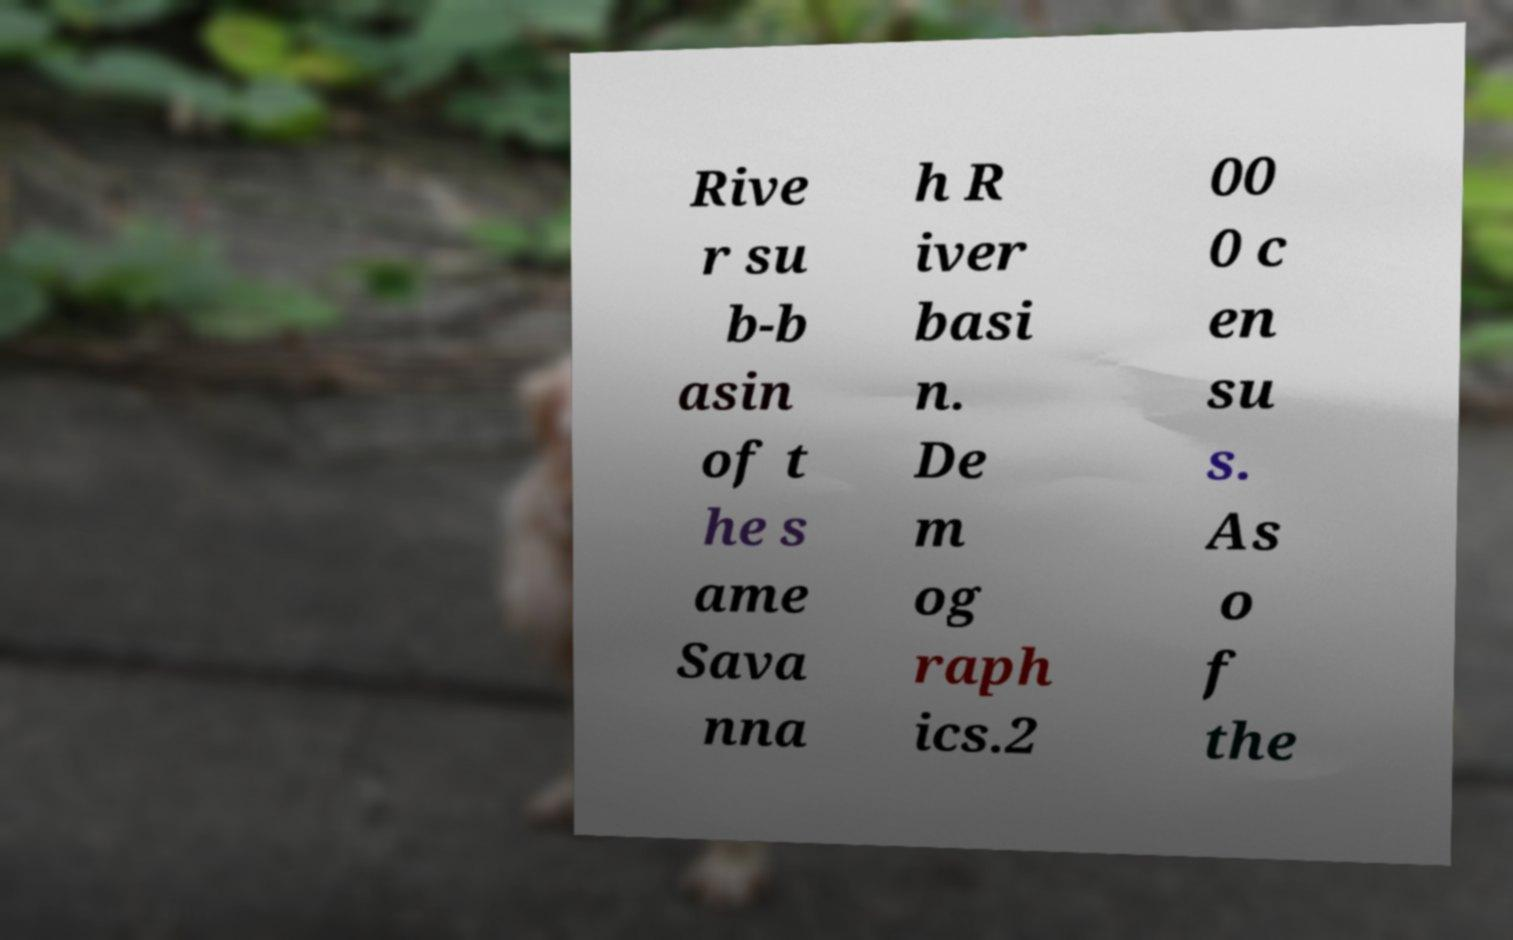What messages or text are displayed in this image? I need them in a readable, typed format. Rive r su b-b asin of t he s ame Sava nna h R iver basi n. De m og raph ics.2 00 0 c en su s. As o f the 